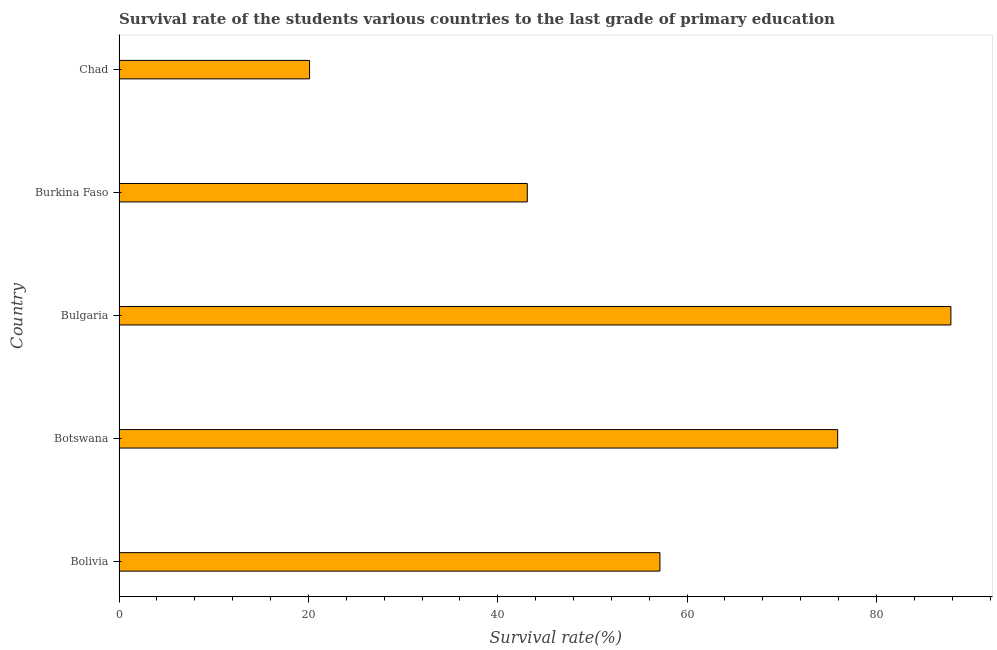Does the graph contain grids?
Give a very brief answer. No. What is the title of the graph?
Your answer should be very brief. Survival rate of the students various countries to the last grade of primary education. What is the label or title of the X-axis?
Provide a succinct answer. Survival rate(%). What is the label or title of the Y-axis?
Give a very brief answer. Country. What is the survival rate in primary education in Chad?
Your answer should be very brief. 20.12. Across all countries, what is the maximum survival rate in primary education?
Provide a succinct answer. 87.87. Across all countries, what is the minimum survival rate in primary education?
Your answer should be very brief. 20.12. In which country was the survival rate in primary education minimum?
Give a very brief answer. Chad. What is the sum of the survival rate in primary education?
Ensure brevity in your answer.  284.15. What is the difference between the survival rate in primary education in Burkina Faso and Chad?
Ensure brevity in your answer.  23. What is the average survival rate in primary education per country?
Keep it short and to the point. 56.83. What is the median survival rate in primary education?
Make the answer very short. 57.13. What is the ratio of the survival rate in primary education in Bolivia to that in Chad?
Your answer should be very brief. 2.84. Is the difference between the survival rate in primary education in Bolivia and Chad greater than the difference between any two countries?
Offer a terse response. No. What is the difference between the highest and the second highest survival rate in primary education?
Your answer should be very brief. 11.96. Is the sum of the survival rate in primary education in Botswana and Bulgaria greater than the maximum survival rate in primary education across all countries?
Ensure brevity in your answer.  Yes. What is the difference between the highest and the lowest survival rate in primary education?
Your answer should be compact. 67.74. How many bars are there?
Offer a very short reply. 5. Are all the bars in the graph horizontal?
Offer a very short reply. Yes. How many countries are there in the graph?
Give a very brief answer. 5. What is the difference between two consecutive major ticks on the X-axis?
Make the answer very short. 20. What is the Survival rate(%) of Bolivia?
Your answer should be very brief. 57.13. What is the Survival rate(%) of Botswana?
Provide a succinct answer. 75.91. What is the Survival rate(%) in Bulgaria?
Provide a succinct answer. 87.87. What is the Survival rate(%) in Burkina Faso?
Keep it short and to the point. 43.12. What is the Survival rate(%) in Chad?
Your response must be concise. 20.12. What is the difference between the Survival rate(%) in Bolivia and Botswana?
Your response must be concise. -18.78. What is the difference between the Survival rate(%) in Bolivia and Bulgaria?
Ensure brevity in your answer.  -30.74. What is the difference between the Survival rate(%) in Bolivia and Burkina Faso?
Give a very brief answer. 14.01. What is the difference between the Survival rate(%) in Bolivia and Chad?
Your response must be concise. 37.01. What is the difference between the Survival rate(%) in Botswana and Bulgaria?
Make the answer very short. -11.96. What is the difference between the Survival rate(%) in Botswana and Burkina Faso?
Offer a terse response. 32.79. What is the difference between the Survival rate(%) in Botswana and Chad?
Keep it short and to the point. 55.78. What is the difference between the Survival rate(%) in Bulgaria and Burkina Faso?
Ensure brevity in your answer.  44.74. What is the difference between the Survival rate(%) in Bulgaria and Chad?
Make the answer very short. 67.74. What is the difference between the Survival rate(%) in Burkina Faso and Chad?
Your answer should be very brief. 23. What is the ratio of the Survival rate(%) in Bolivia to that in Botswana?
Ensure brevity in your answer.  0.75. What is the ratio of the Survival rate(%) in Bolivia to that in Bulgaria?
Make the answer very short. 0.65. What is the ratio of the Survival rate(%) in Bolivia to that in Burkina Faso?
Your answer should be compact. 1.32. What is the ratio of the Survival rate(%) in Bolivia to that in Chad?
Offer a terse response. 2.84. What is the ratio of the Survival rate(%) in Botswana to that in Bulgaria?
Provide a short and direct response. 0.86. What is the ratio of the Survival rate(%) in Botswana to that in Burkina Faso?
Give a very brief answer. 1.76. What is the ratio of the Survival rate(%) in Botswana to that in Chad?
Offer a terse response. 3.77. What is the ratio of the Survival rate(%) in Bulgaria to that in Burkina Faso?
Keep it short and to the point. 2.04. What is the ratio of the Survival rate(%) in Bulgaria to that in Chad?
Provide a succinct answer. 4.37. What is the ratio of the Survival rate(%) in Burkina Faso to that in Chad?
Your response must be concise. 2.14. 